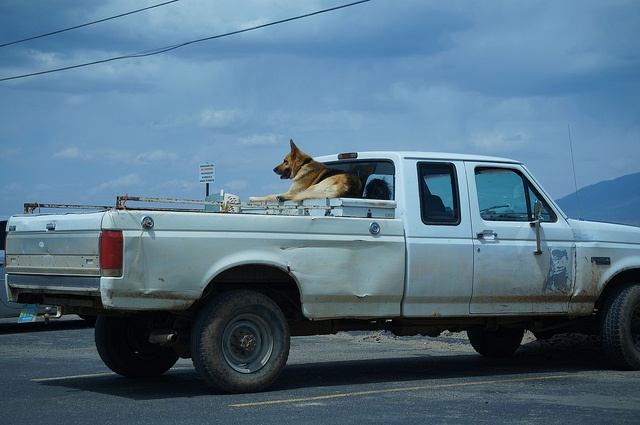Describe the objects in this image and their specific colors. I can see truck in gray, black, and darkgray tones, dog in gray, black, darkgray, olive, and tan tones, and people in gray, black, blue, and teal tones in this image. 